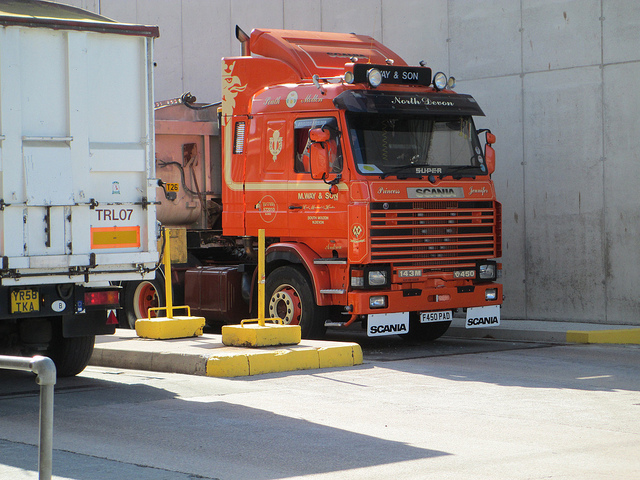Read all the text in this image. SCANIA SCANIA NORTH & SON B TKA YR58 143M TRL07 